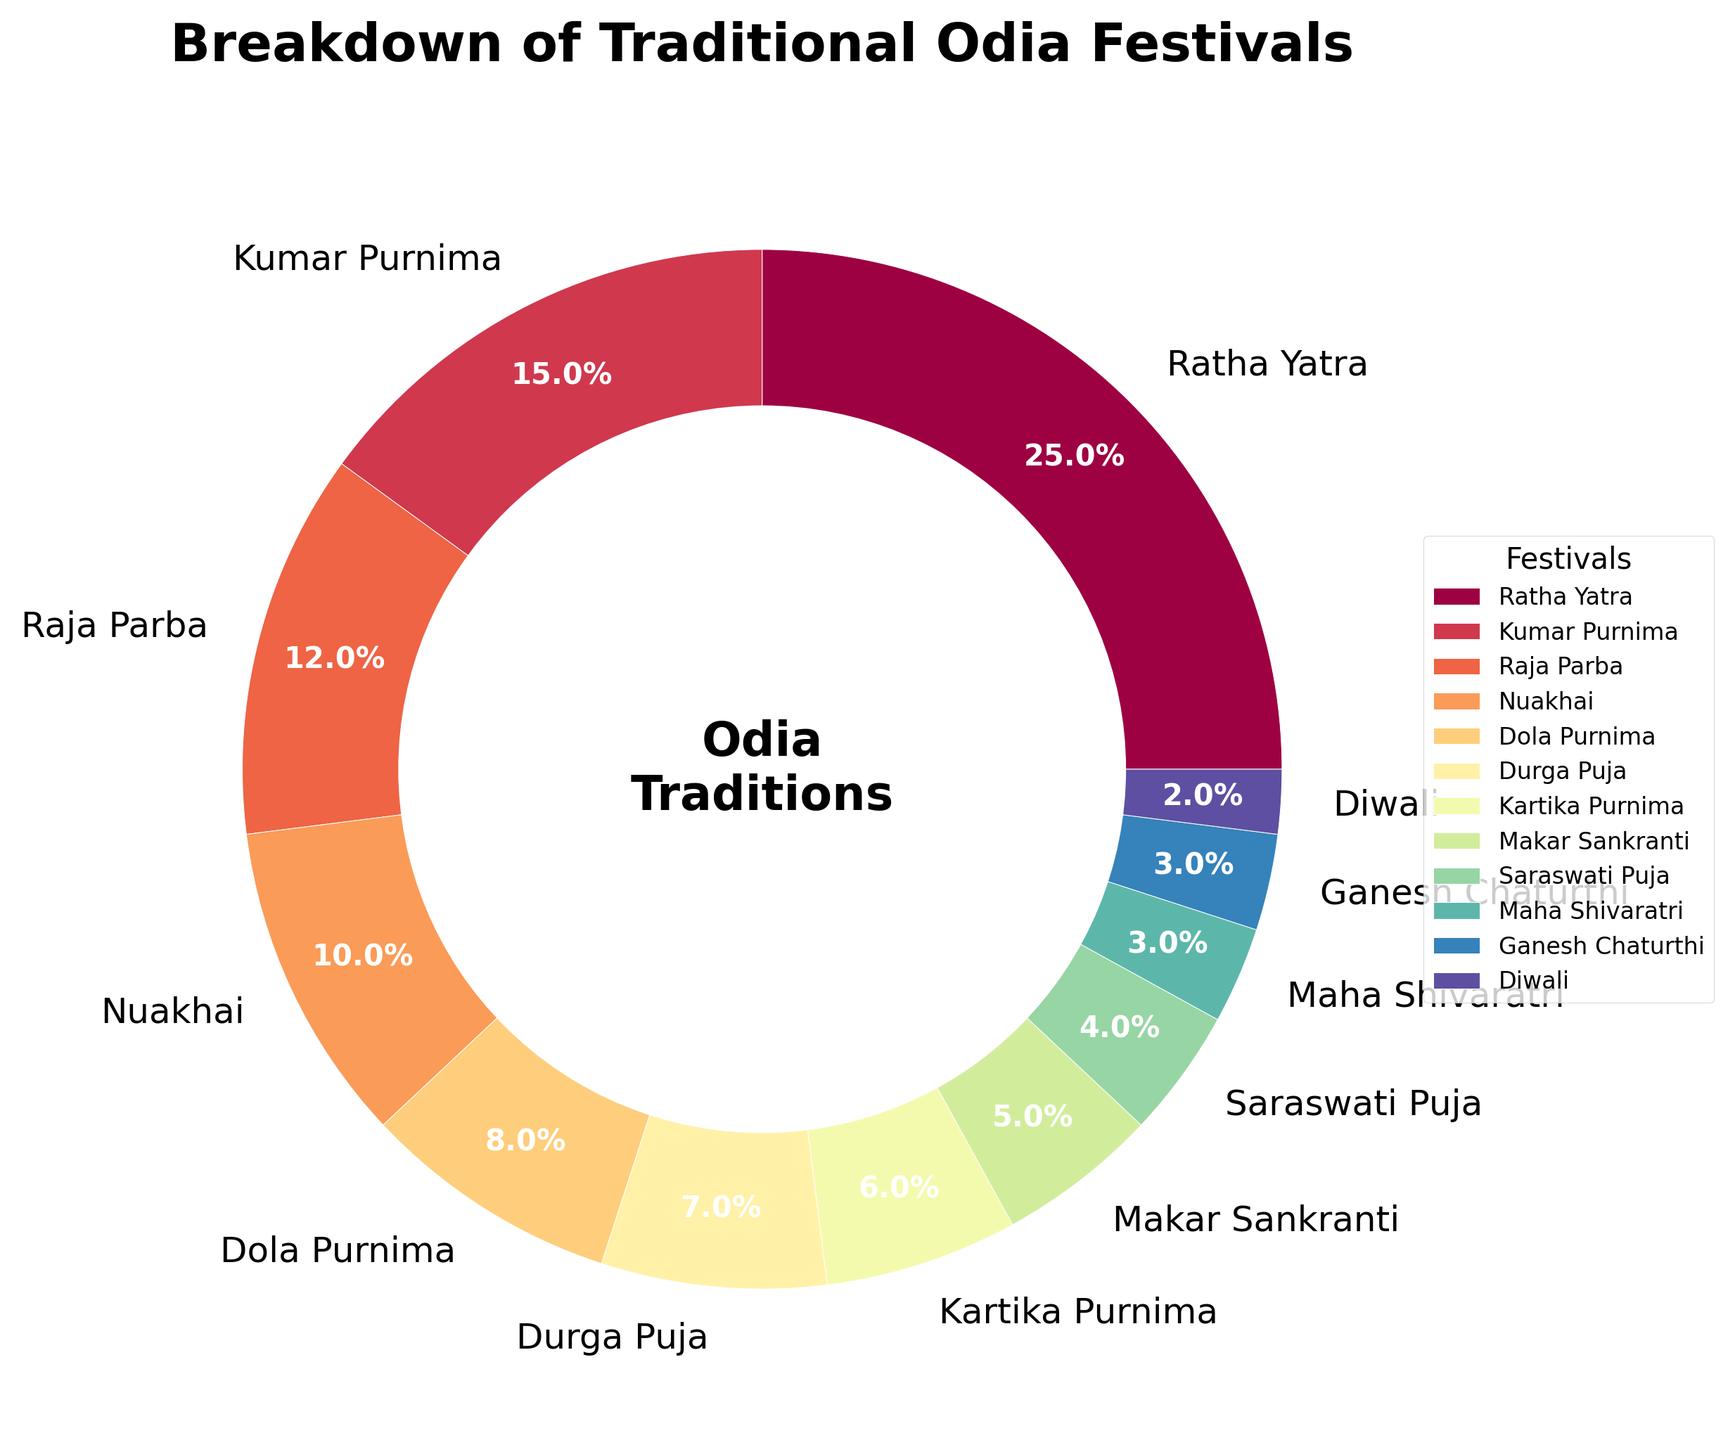What is the most celebrated Odia festival? The pie chart shows the portion of each festival. The largest section represents Ratha Yatra at 25%.
Answer: Ratha Yatra How many percent more is Ratha Yatra celebrated than Kumar Purnima? Ratha Yatra is 25% and Kumar Purnima is 15%. The difference is 25% - 15%.
Answer: 10% Which festival has a smaller percentage, Ganesh Chaturthi or Diwali? Both Ganesh Chaturthi and Diwali are small, but Diwali is 2% and Ganesh Chaturthi is 3%. Thus, Diwali is smaller.
Answer: Diwali What is the combined percentage of Nuakhai and Dola Purnima? Nuakhai is 10% and Dola Purnima is 8%. Adding them together: 10% + 8%.
Answer: 18% Which festivals sum up to 12%? Only Raja Parba has an exact 12% portion in the pie chart.
Answer: Raja Parba Which festival has a similar percentage to Kartika Purnima and Makar Sankranti combined? Kartika Purnima is 6% and Makar Sankranti is 5%. Combined, they are 6% + 5% = 11%.
Answer: No single festival has this percentage How much more is Ratha Yatra celebrated compared to Saraswati Puja? Ratha Yatra is celebrated at 25% and Saraswati Puja is at 4%. The difference is 25% - 4%.
Answer: 21% Calculate the total percentage of festivals celebrated less than 5%. Diwali (2%), Maha Shivaratri (3%), and Ganesh Chaturthi (3%) are all below 5%. Summing them gives: 2% + 3% + 3%.
Answer: 8% Which festival is celebrated more, Durga Puja or Dola Purnima? Durga Puja is at 7% and Dola Purnima is at 8%. Thus, Dola Purnima is celebrated more.
Answer: Dola Purnima 